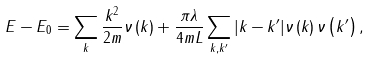<formula> <loc_0><loc_0><loc_500><loc_500>E - E _ { 0 } = \sum _ { k } \frac { k ^ { 2 } } { 2 m } \nu \left ( k \right ) + \frac { \pi \lambda } { 4 m L } \sum _ { k , k ^ { \prime } } | k - k ^ { \prime } | \nu \left ( k \right ) \nu \left ( k ^ { \prime } \right ) ,</formula> 